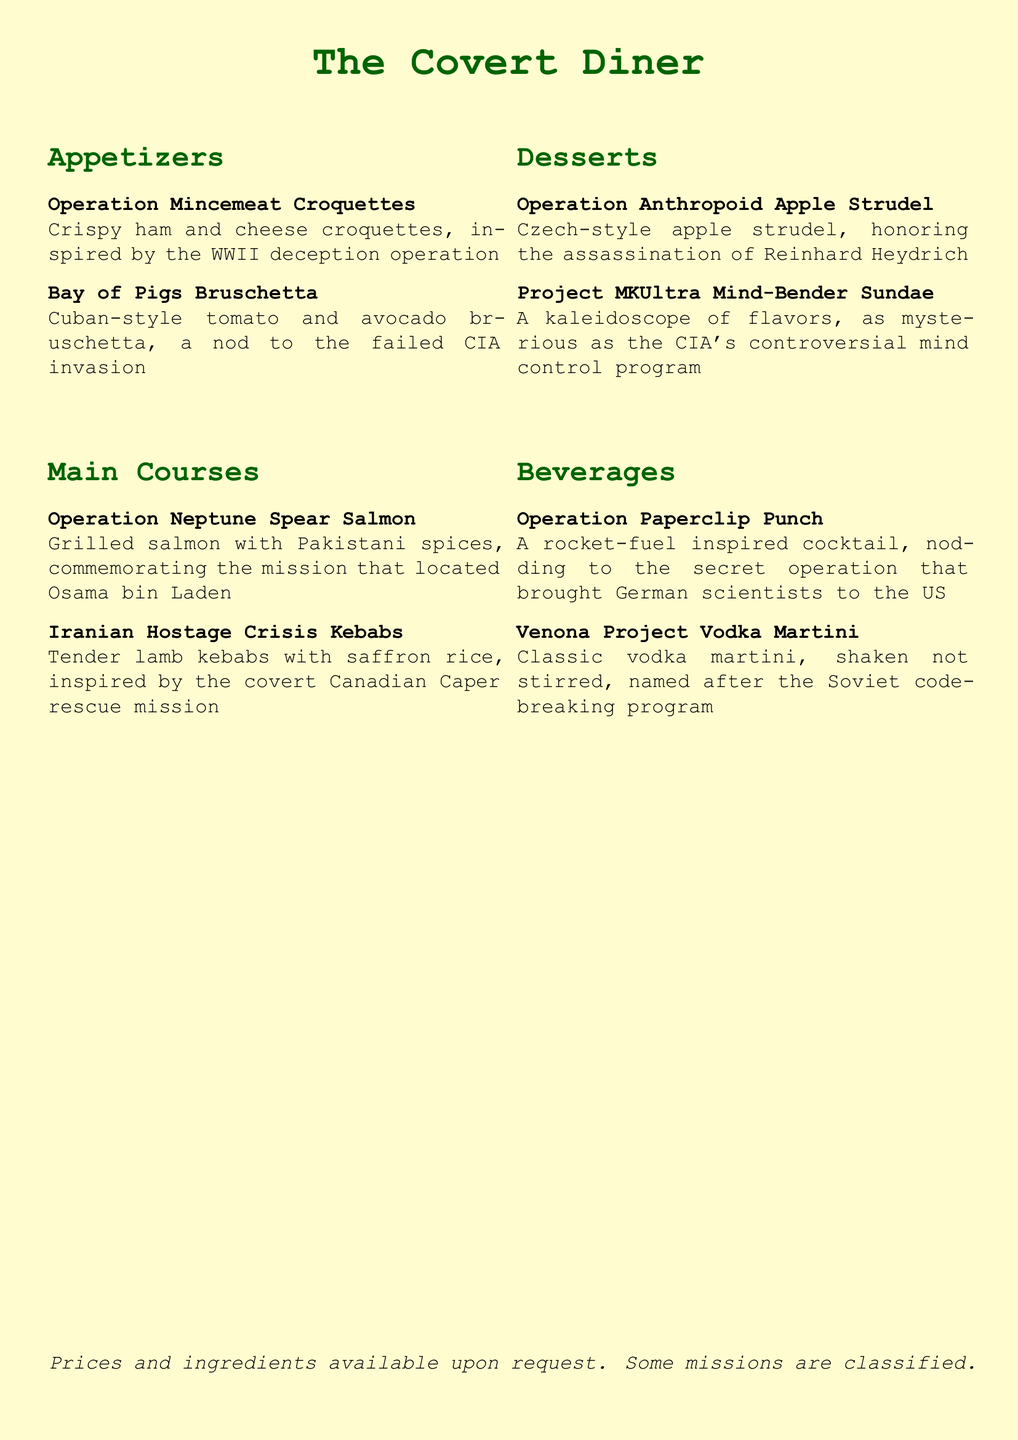What is the name of the restaurant? The name of the restaurant is prominently displayed at the top of the document.
Answer: The Covert Diner What dish is inspired by a WWII deception operation? This information can be found in the appetizers section where specific dishes are described.
Answer: Operation Mincemeat Croquettes Which dish honors the assassination of Reinhard Heydrich? The dessert section contains dishes that pay homage to specific historical events or figures.
Answer: Operation Anthropoid Apple Strudel What type of meat is used in the Iranian Hostage Crisis Kebabs? The description of the dish provides specific details about the main ingredient.
Answer: Lamb What beverage is named after a Soviet code-breaking program? The beverages section lists drinks with specific names related to historical operations.
Answer: Venona Project Vodka Martini How many sections are listed in the menu? The layout of the document reveals the number of distinct sections within the menu.
Answer: Four What flavor is the Project MKUltra Mind-Bender Sundae described as? The dessert section includes adjectives to describe the sundae, giving insight into its character.
Answer: Mysterious Which appetizer is a nod to a failed CIA invasion? The appetizers section specifically mentions historical references related to certain dishes.
Answer: Bay of Pigs Bruschetta What is stated about prices and ingredients? The concluding statement provides important information regarding inquiries about dishes.
Answer: Available upon request 